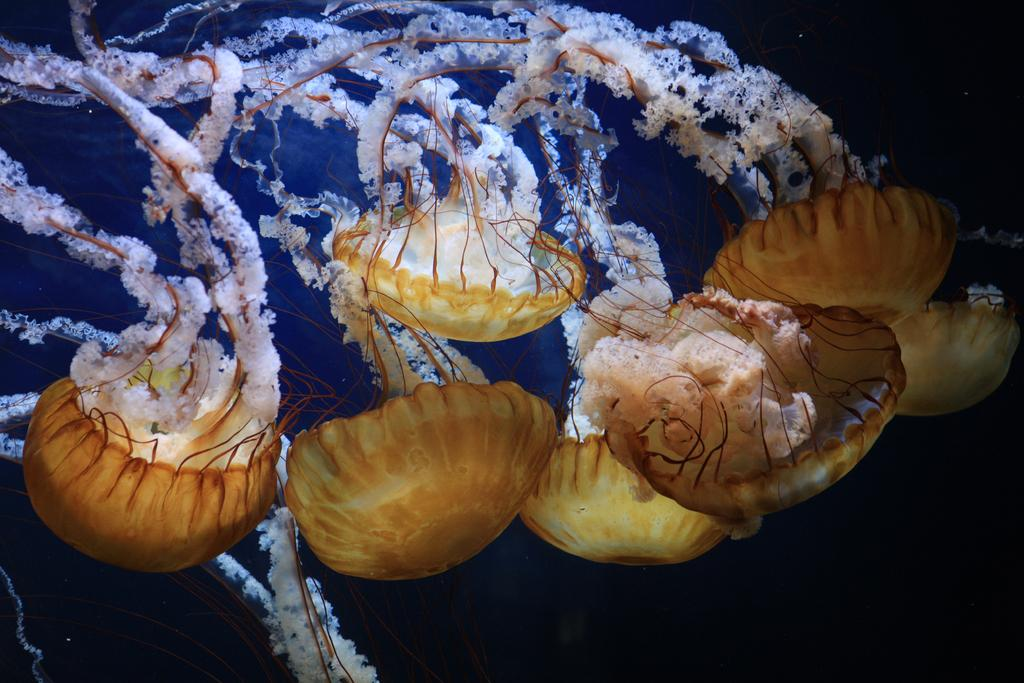What type of sea creatures are present in the image? There are jellyfishes in the image. Can you describe the appearance of the jellyfishes? The jellyfishes have a translucent, gelatinous body with long, trailing tentacles. What might be the natural habitat of these creatures? Jellyfishes are typically found in oceans and seas around the world. How many mice are playing with a beetle in the image? There are no mice or beetles present in the image; it features jellyfishes. What type of sisters can be seen interacting with the jellyfishes in the image? There are no sisters present in the image; it only features jellyfishes. 